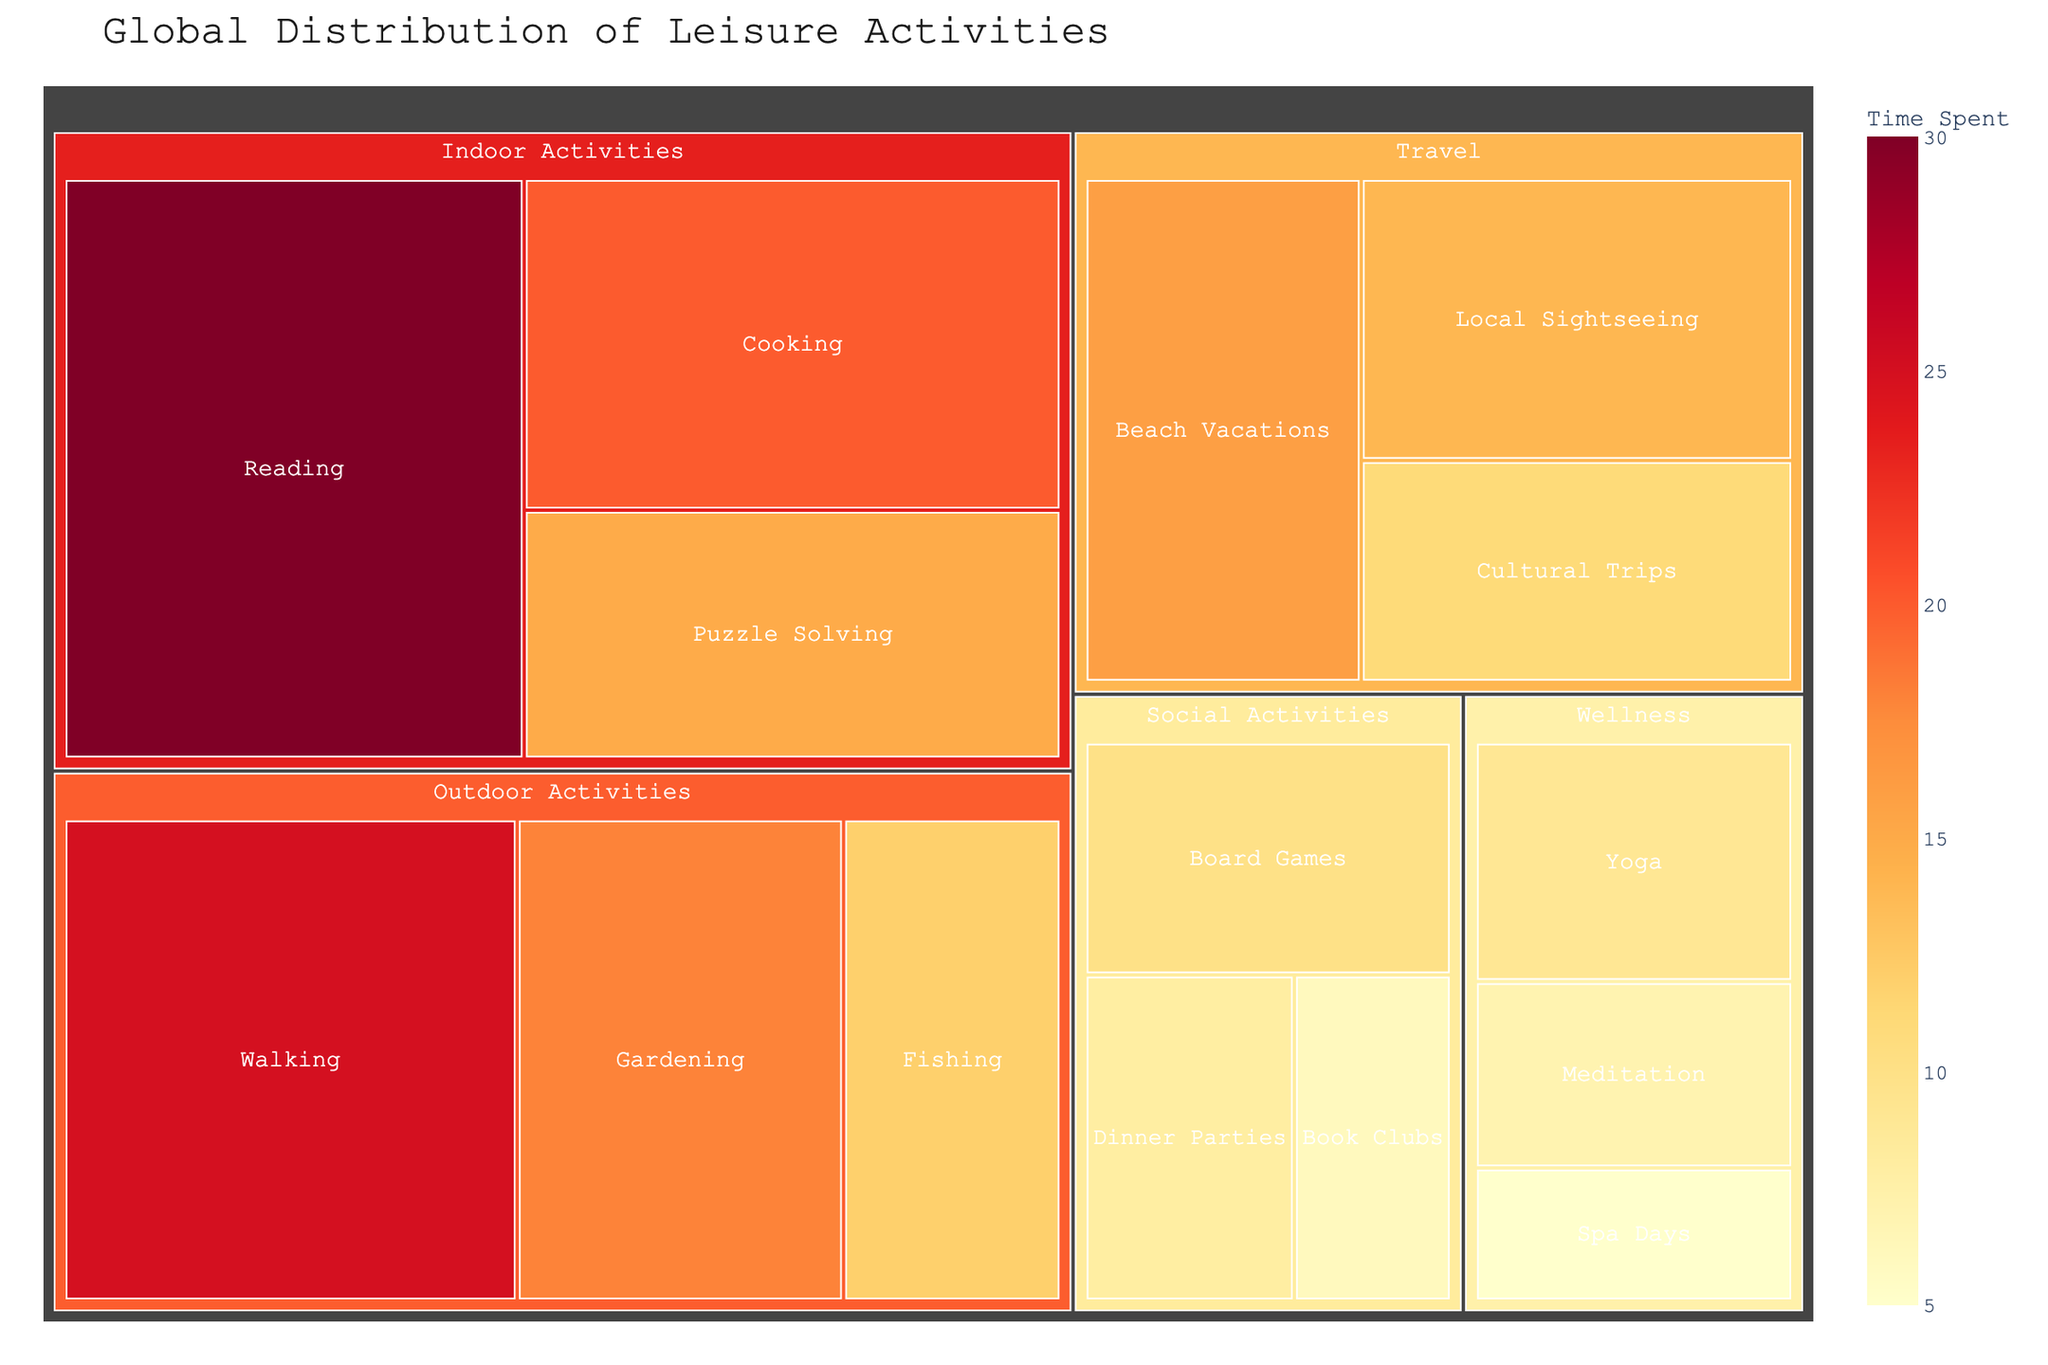what is the title of the figure? The title of a plot is usually displayed at the top of the figure in a larger font size. By looking at the top section of the treemap, we can see the title.
Answer: Global Distribution of Leisure Activities which category has the highest time spent? To answer this, we need to look at the largest sections of the treemap, as size represents the value. By comparing all categories, we see which one is the largest.
Answer: Indoor Activities How much time is spent on Cooking? Locate the Cooking subcategory within the Indoor Activities category. The time spent is indicated by the size of this subcategory's block.
Answer: 20 What's the difference in time spent between Board Games and Yoga? Look at the time values associated with Board Games and Yoga subcategories. Subtract the smaller value from the larger value to find the difference.
Answer: 1 Which activity within Outdoor Activities is the most popular? Compare the size of the blocks within the Outdoor Activities category to see which is the largest.
Answer: Walking How many subcategories are there in total? Count the number of individual blocks that fall under each category in the treemap.
Answer: 15 what is the least popular activity in the figure? Identify the smallest block on the treemap, as this represents the least time spent.
Answer: Spa Days Which has more time spent, Cultural Trips or Local Sightseeing? Compare the sizes of the Cultural Trips and Local Sightseeing blocks to see which one is larger.
Answer: Local Sightseeing Sum the time spent on all Social Activities subcategories. Add the values of Board Games, Dinner Parties, and Book Clubs, which are all within the Social Activities category.
Answer: 24 How many activities are there in the Travel category? Count the number of subcategories listed under the Travel category.
Answer: 3 